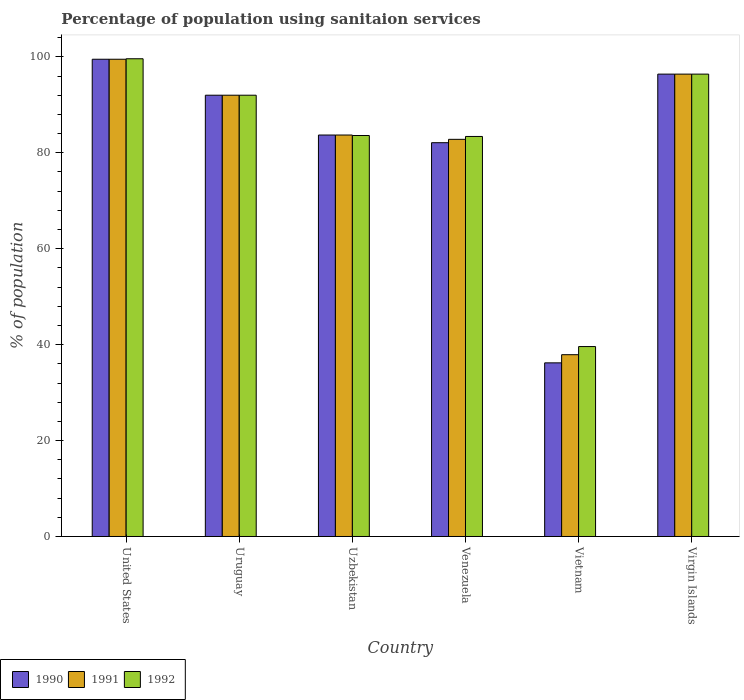How many different coloured bars are there?
Your answer should be very brief. 3. Are the number of bars on each tick of the X-axis equal?
Provide a short and direct response. Yes. What is the label of the 4th group of bars from the left?
Offer a very short reply. Venezuela. In how many cases, is the number of bars for a given country not equal to the number of legend labels?
Your response must be concise. 0. What is the percentage of population using sanitaion services in 1990 in United States?
Ensure brevity in your answer.  99.5. Across all countries, what is the maximum percentage of population using sanitaion services in 1990?
Your answer should be very brief. 99.5. Across all countries, what is the minimum percentage of population using sanitaion services in 1990?
Make the answer very short. 36.2. In which country was the percentage of population using sanitaion services in 1990 maximum?
Keep it short and to the point. United States. In which country was the percentage of population using sanitaion services in 1992 minimum?
Your answer should be compact. Vietnam. What is the total percentage of population using sanitaion services in 1991 in the graph?
Provide a succinct answer. 492.3. What is the difference between the percentage of population using sanitaion services in 1990 in Uzbekistan and that in Venezuela?
Offer a terse response. 1.6. What is the difference between the percentage of population using sanitaion services in 1991 in Vietnam and the percentage of population using sanitaion services in 1990 in Uzbekistan?
Offer a very short reply. -45.8. What is the average percentage of population using sanitaion services in 1992 per country?
Your answer should be compact. 82.43. What is the difference between the percentage of population using sanitaion services of/in 1991 and percentage of population using sanitaion services of/in 1992 in Venezuela?
Ensure brevity in your answer.  -0.6. What is the ratio of the percentage of population using sanitaion services in 1990 in Venezuela to that in Virgin Islands?
Your response must be concise. 0.85. Is the percentage of population using sanitaion services in 1992 in Uzbekistan less than that in Vietnam?
Offer a terse response. No. Is the difference between the percentage of population using sanitaion services in 1991 in Vietnam and Virgin Islands greater than the difference between the percentage of population using sanitaion services in 1992 in Vietnam and Virgin Islands?
Keep it short and to the point. No. What is the difference between the highest and the second highest percentage of population using sanitaion services in 1992?
Your answer should be compact. -3.2. What is the difference between the highest and the lowest percentage of population using sanitaion services in 1991?
Offer a very short reply. 61.6. In how many countries, is the percentage of population using sanitaion services in 1990 greater than the average percentage of population using sanitaion services in 1990 taken over all countries?
Your response must be concise. 5. What does the 3rd bar from the left in Vietnam represents?
Offer a very short reply. 1992. What does the 2nd bar from the right in Venezuela represents?
Make the answer very short. 1991. Is it the case that in every country, the sum of the percentage of population using sanitaion services in 1990 and percentage of population using sanitaion services in 1992 is greater than the percentage of population using sanitaion services in 1991?
Make the answer very short. Yes. Are all the bars in the graph horizontal?
Provide a short and direct response. No. What is the difference between two consecutive major ticks on the Y-axis?
Provide a succinct answer. 20. How many legend labels are there?
Ensure brevity in your answer.  3. What is the title of the graph?
Offer a terse response. Percentage of population using sanitaion services. What is the label or title of the Y-axis?
Keep it short and to the point. % of population. What is the % of population of 1990 in United States?
Provide a succinct answer. 99.5. What is the % of population in 1991 in United States?
Your answer should be compact. 99.5. What is the % of population of 1992 in United States?
Ensure brevity in your answer.  99.6. What is the % of population of 1990 in Uruguay?
Your response must be concise. 92. What is the % of population of 1991 in Uruguay?
Offer a terse response. 92. What is the % of population in 1992 in Uruguay?
Your response must be concise. 92. What is the % of population of 1990 in Uzbekistan?
Offer a terse response. 83.7. What is the % of population of 1991 in Uzbekistan?
Provide a short and direct response. 83.7. What is the % of population of 1992 in Uzbekistan?
Give a very brief answer. 83.6. What is the % of population in 1990 in Venezuela?
Provide a short and direct response. 82.1. What is the % of population in 1991 in Venezuela?
Your answer should be compact. 82.8. What is the % of population in 1992 in Venezuela?
Your response must be concise. 83.4. What is the % of population of 1990 in Vietnam?
Make the answer very short. 36.2. What is the % of population in 1991 in Vietnam?
Offer a terse response. 37.9. What is the % of population in 1992 in Vietnam?
Give a very brief answer. 39.6. What is the % of population in 1990 in Virgin Islands?
Ensure brevity in your answer.  96.4. What is the % of population of 1991 in Virgin Islands?
Offer a very short reply. 96.4. What is the % of population in 1992 in Virgin Islands?
Ensure brevity in your answer.  96.4. Across all countries, what is the maximum % of population of 1990?
Your answer should be very brief. 99.5. Across all countries, what is the maximum % of population in 1991?
Keep it short and to the point. 99.5. Across all countries, what is the maximum % of population in 1992?
Offer a very short reply. 99.6. Across all countries, what is the minimum % of population of 1990?
Offer a terse response. 36.2. Across all countries, what is the minimum % of population in 1991?
Offer a very short reply. 37.9. Across all countries, what is the minimum % of population of 1992?
Ensure brevity in your answer.  39.6. What is the total % of population of 1990 in the graph?
Your response must be concise. 489.9. What is the total % of population in 1991 in the graph?
Your response must be concise. 492.3. What is the total % of population in 1992 in the graph?
Provide a succinct answer. 494.6. What is the difference between the % of population of 1990 in United States and that in Uruguay?
Make the answer very short. 7.5. What is the difference between the % of population in 1991 in United States and that in Uruguay?
Your answer should be very brief. 7.5. What is the difference between the % of population of 1992 in United States and that in Uruguay?
Your response must be concise. 7.6. What is the difference between the % of population in 1990 in United States and that in Uzbekistan?
Provide a short and direct response. 15.8. What is the difference between the % of population of 1992 in United States and that in Uzbekistan?
Keep it short and to the point. 16. What is the difference between the % of population of 1991 in United States and that in Venezuela?
Your response must be concise. 16.7. What is the difference between the % of population of 1990 in United States and that in Vietnam?
Ensure brevity in your answer.  63.3. What is the difference between the % of population of 1991 in United States and that in Vietnam?
Provide a short and direct response. 61.6. What is the difference between the % of population in 1990 in United States and that in Virgin Islands?
Keep it short and to the point. 3.1. What is the difference between the % of population of 1991 in United States and that in Virgin Islands?
Offer a very short reply. 3.1. What is the difference between the % of population of 1992 in United States and that in Virgin Islands?
Make the answer very short. 3.2. What is the difference between the % of population in 1991 in Uruguay and that in Uzbekistan?
Give a very brief answer. 8.3. What is the difference between the % of population of 1991 in Uruguay and that in Venezuela?
Provide a succinct answer. 9.2. What is the difference between the % of population in 1990 in Uruguay and that in Vietnam?
Offer a very short reply. 55.8. What is the difference between the % of population in 1991 in Uruguay and that in Vietnam?
Provide a short and direct response. 54.1. What is the difference between the % of population in 1992 in Uruguay and that in Vietnam?
Ensure brevity in your answer.  52.4. What is the difference between the % of population of 1991 in Uruguay and that in Virgin Islands?
Your response must be concise. -4.4. What is the difference between the % of population in 1991 in Uzbekistan and that in Venezuela?
Provide a succinct answer. 0.9. What is the difference between the % of population of 1990 in Uzbekistan and that in Vietnam?
Offer a very short reply. 47.5. What is the difference between the % of population of 1991 in Uzbekistan and that in Vietnam?
Provide a short and direct response. 45.8. What is the difference between the % of population of 1990 in Uzbekistan and that in Virgin Islands?
Keep it short and to the point. -12.7. What is the difference between the % of population of 1991 in Uzbekistan and that in Virgin Islands?
Ensure brevity in your answer.  -12.7. What is the difference between the % of population in 1992 in Uzbekistan and that in Virgin Islands?
Your answer should be very brief. -12.8. What is the difference between the % of population of 1990 in Venezuela and that in Vietnam?
Offer a very short reply. 45.9. What is the difference between the % of population of 1991 in Venezuela and that in Vietnam?
Ensure brevity in your answer.  44.9. What is the difference between the % of population in 1992 in Venezuela and that in Vietnam?
Make the answer very short. 43.8. What is the difference between the % of population of 1990 in Venezuela and that in Virgin Islands?
Offer a very short reply. -14.3. What is the difference between the % of population in 1990 in Vietnam and that in Virgin Islands?
Your answer should be compact. -60.2. What is the difference between the % of population in 1991 in Vietnam and that in Virgin Islands?
Give a very brief answer. -58.5. What is the difference between the % of population in 1992 in Vietnam and that in Virgin Islands?
Make the answer very short. -56.8. What is the difference between the % of population in 1990 in United States and the % of population in 1991 in Uruguay?
Your answer should be compact. 7.5. What is the difference between the % of population of 1990 in United States and the % of population of 1992 in Uzbekistan?
Offer a very short reply. 15.9. What is the difference between the % of population in 1991 in United States and the % of population in 1992 in Uzbekistan?
Provide a succinct answer. 15.9. What is the difference between the % of population in 1990 in United States and the % of population in 1991 in Venezuela?
Your response must be concise. 16.7. What is the difference between the % of population of 1990 in United States and the % of population of 1991 in Vietnam?
Ensure brevity in your answer.  61.6. What is the difference between the % of population of 1990 in United States and the % of population of 1992 in Vietnam?
Ensure brevity in your answer.  59.9. What is the difference between the % of population of 1991 in United States and the % of population of 1992 in Vietnam?
Offer a terse response. 59.9. What is the difference between the % of population of 1991 in United States and the % of population of 1992 in Virgin Islands?
Offer a terse response. 3.1. What is the difference between the % of population in 1990 in Uruguay and the % of population in 1992 in Venezuela?
Your response must be concise. 8.6. What is the difference between the % of population of 1991 in Uruguay and the % of population of 1992 in Venezuela?
Your response must be concise. 8.6. What is the difference between the % of population of 1990 in Uruguay and the % of population of 1991 in Vietnam?
Give a very brief answer. 54.1. What is the difference between the % of population of 1990 in Uruguay and the % of population of 1992 in Vietnam?
Keep it short and to the point. 52.4. What is the difference between the % of population in 1991 in Uruguay and the % of population in 1992 in Vietnam?
Make the answer very short. 52.4. What is the difference between the % of population of 1990 in Uruguay and the % of population of 1991 in Virgin Islands?
Ensure brevity in your answer.  -4.4. What is the difference between the % of population in 1990 in Uruguay and the % of population in 1992 in Virgin Islands?
Make the answer very short. -4.4. What is the difference between the % of population in 1990 in Uzbekistan and the % of population in 1992 in Venezuela?
Your answer should be compact. 0.3. What is the difference between the % of population of 1990 in Uzbekistan and the % of population of 1991 in Vietnam?
Give a very brief answer. 45.8. What is the difference between the % of population in 1990 in Uzbekistan and the % of population in 1992 in Vietnam?
Provide a succinct answer. 44.1. What is the difference between the % of population of 1991 in Uzbekistan and the % of population of 1992 in Vietnam?
Your answer should be very brief. 44.1. What is the difference between the % of population in 1990 in Uzbekistan and the % of population in 1991 in Virgin Islands?
Offer a terse response. -12.7. What is the difference between the % of population of 1990 in Venezuela and the % of population of 1991 in Vietnam?
Offer a terse response. 44.2. What is the difference between the % of population in 1990 in Venezuela and the % of population in 1992 in Vietnam?
Make the answer very short. 42.5. What is the difference between the % of population in 1991 in Venezuela and the % of population in 1992 in Vietnam?
Your answer should be compact. 43.2. What is the difference between the % of population of 1990 in Venezuela and the % of population of 1991 in Virgin Islands?
Your answer should be very brief. -14.3. What is the difference between the % of population of 1990 in Venezuela and the % of population of 1992 in Virgin Islands?
Your answer should be very brief. -14.3. What is the difference between the % of population in 1991 in Venezuela and the % of population in 1992 in Virgin Islands?
Your response must be concise. -13.6. What is the difference between the % of population of 1990 in Vietnam and the % of population of 1991 in Virgin Islands?
Make the answer very short. -60.2. What is the difference between the % of population in 1990 in Vietnam and the % of population in 1992 in Virgin Islands?
Your answer should be very brief. -60.2. What is the difference between the % of population in 1991 in Vietnam and the % of population in 1992 in Virgin Islands?
Give a very brief answer. -58.5. What is the average % of population in 1990 per country?
Your answer should be very brief. 81.65. What is the average % of population in 1991 per country?
Your response must be concise. 82.05. What is the average % of population in 1992 per country?
Keep it short and to the point. 82.43. What is the difference between the % of population in 1990 and % of population in 1991 in United States?
Offer a very short reply. 0. What is the difference between the % of population of 1990 and % of population of 1992 in United States?
Ensure brevity in your answer.  -0.1. What is the difference between the % of population of 1991 and % of population of 1992 in United States?
Your answer should be very brief. -0.1. What is the difference between the % of population of 1990 and % of population of 1991 in Uruguay?
Keep it short and to the point. 0. What is the difference between the % of population in 1990 and % of population in 1992 in Uzbekistan?
Ensure brevity in your answer.  0.1. What is the difference between the % of population in 1991 and % of population in 1992 in Uzbekistan?
Make the answer very short. 0.1. What is the difference between the % of population in 1990 and % of population in 1991 in Venezuela?
Your answer should be very brief. -0.7. What is the difference between the % of population of 1991 and % of population of 1992 in Venezuela?
Your response must be concise. -0.6. What is the difference between the % of population in 1990 and % of population in 1991 in Vietnam?
Make the answer very short. -1.7. What is the difference between the % of population in 1991 and % of population in 1992 in Vietnam?
Provide a short and direct response. -1.7. What is the difference between the % of population of 1990 and % of population of 1992 in Virgin Islands?
Offer a very short reply. 0. What is the ratio of the % of population of 1990 in United States to that in Uruguay?
Ensure brevity in your answer.  1.08. What is the ratio of the % of population in 1991 in United States to that in Uruguay?
Offer a very short reply. 1.08. What is the ratio of the % of population in 1992 in United States to that in Uruguay?
Provide a succinct answer. 1.08. What is the ratio of the % of population of 1990 in United States to that in Uzbekistan?
Provide a succinct answer. 1.19. What is the ratio of the % of population in 1991 in United States to that in Uzbekistan?
Make the answer very short. 1.19. What is the ratio of the % of population of 1992 in United States to that in Uzbekistan?
Provide a short and direct response. 1.19. What is the ratio of the % of population in 1990 in United States to that in Venezuela?
Make the answer very short. 1.21. What is the ratio of the % of population of 1991 in United States to that in Venezuela?
Give a very brief answer. 1.2. What is the ratio of the % of population of 1992 in United States to that in Venezuela?
Ensure brevity in your answer.  1.19. What is the ratio of the % of population in 1990 in United States to that in Vietnam?
Your answer should be compact. 2.75. What is the ratio of the % of population of 1991 in United States to that in Vietnam?
Offer a very short reply. 2.63. What is the ratio of the % of population of 1992 in United States to that in Vietnam?
Offer a terse response. 2.52. What is the ratio of the % of population of 1990 in United States to that in Virgin Islands?
Offer a terse response. 1.03. What is the ratio of the % of population in 1991 in United States to that in Virgin Islands?
Your answer should be very brief. 1.03. What is the ratio of the % of population in 1992 in United States to that in Virgin Islands?
Keep it short and to the point. 1.03. What is the ratio of the % of population of 1990 in Uruguay to that in Uzbekistan?
Provide a succinct answer. 1.1. What is the ratio of the % of population in 1991 in Uruguay to that in Uzbekistan?
Provide a succinct answer. 1.1. What is the ratio of the % of population of 1992 in Uruguay to that in Uzbekistan?
Make the answer very short. 1.1. What is the ratio of the % of population of 1990 in Uruguay to that in Venezuela?
Make the answer very short. 1.12. What is the ratio of the % of population in 1992 in Uruguay to that in Venezuela?
Your answer should be compact. 1.1. What is the ratio of the % of population in 1990 in Uruguay to that in Vietnam?
Provide a succinct answer. 2.54. What is the ratio of the % of population in 1991 in Uruguay to that in Vietnam?
Your response must be concise. 2.43. What is the ratio of the % of population of 1992 in Uruguay to that in Vietnam?
Offer a terse response. 2.32. What is the ratio of the % of population of 1990 in Uruguay to that in Virgin Islands?
Offer a very short reply. 0.95. What is the ratio of the % of population of 1991 in Uruguay to that in Virgin Islands?
Your answer should be compact. 0.95. What is the ratio of the % of population of 1992 in Uruguay to that in Virgin Islands?
Provide a short and direct response. 0.95. What is the ratio of the % of population in 1990 in Uzbekistan to that in Venezuela?
Ensure brevity in your answer.  1.02. What is the ratio of the % of population of 1991 in Uzbekistan to that in Venezuela?
Make the answer very short. 1.01. What is the ratio of the % of population of 1992 in Uzbekistan to that in Venezuela?
Ensure brevity in your answer.  1. What is the ratio of the % of population in 1990 in Uzbekistan to that in Vietnam?
Keep it short and to the point. 2.31. What is the ratio of the % of population of 1991 in Uzbekistan to that in Vietnam?
Give a very brief answer. 2.21. What is the ratio of the % of population in 1992 in Uzbekistan to that in Vietnam?
Provide a short and direct response. 2.11. What is the ratio of the % of population of 1990 in Uzbekistan to that in Virgin Islands?
Offer a very short reply. 0.87. What is the ratio of the % of population of 1991 in Uzbekistan to that in Virgin Islands?
Keep it short and to the point. 0.87. What is the ratio of the % of population of 1992 in Uzbekistan to that in Virgin Islands?
Provide a short and direct response. 0.87. What is the ratio of the % of population in 1990 in Venezuela to that in Vietnam?
Your answer should be compact. 2.27. What is the ratio of the % of population in 1991 in Venezuela to that in Vietnam?
Your response must be concise. 2.18. What is the ratio of the % of population in 1992 in Venezuela to that in Vietnam?
Your answer should be compact. 2.11. What is the ratio of the % of population in 1990 in Venezuela to that in Virgin Islands?
Your response must be concise. 0.85. What is the ratio of the % of population in 1991 in Venezuela to that in Virgin Islands?
Provide a succinct answer. 0.86. What is the ratio of the % of population in 1992 in Venezuela to that in Virgin Islands?
Keep it short and to the point. 0.87. What is the ratio of the % of population of 1990 in Vietnam to that in Virgin Islands?
Keep it short and to the point. 0.38. What is the ratio of the % of population of 1991 in Vietnam to that in Virgin Islands?
Your answer should be very brief. 0.39. What is the ratio of the % of population of 1992 in Vietnam to that in Virgin Islands?
Provide a short and direct response. 0.41. What is the difference between the highest and the lowest % of population of 1990?
Keep it short and to the point. 63.3. What is the difference between the highest and the lowest % of population in 1991?
Offer a terse response. 61.6. 